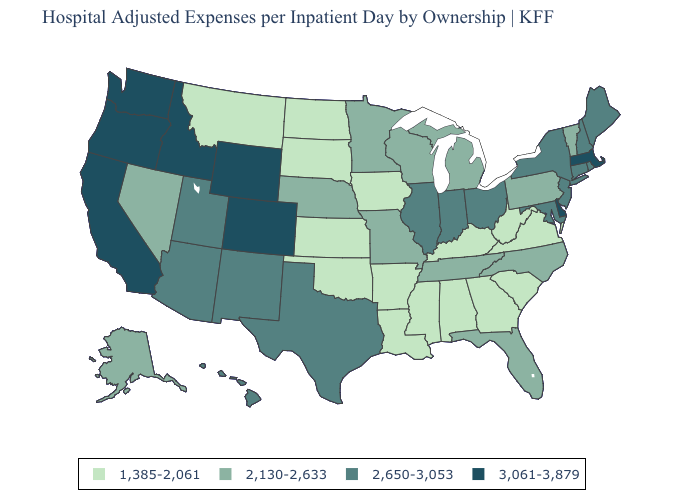Name the states that have a value in the range 2,650-3,053?
Concise answer only. Arizona, Connecticut, Hawaii, Illinois, Indiana, Maine, Maryland, New Hampshire, New Jersey, New Mexico, New York, Ohio, Rhode Island, Texas, Utah. How many symbols are there in the legend?
Answer briefly. 4. What is the lowest value in states that border Nebraska?
Concise answer only. 1,385-2,061. What is the value of Indiana?
Concise answer only. 2,650-3,053. Does North Dakota have the lowest value in the USA?
Short answer required. Yes. Does Colorado have the highest value in the USA?
Short answer required. Yes. Is the legend a continuous bar?
Keep it brief. No. Does Delaware have the highest value in the USA?
Concise answer only. Yes. What is the lowest value in the Northeast?
Give a very brief answer. 2,130-2,633. Which states have the lowest value in the South?
Concise answer only. Alabama, Arkansas, Georgia, Kentucky, Louisiana, Mississippi, Oklahoma, South Carolina, Virginia, West Virginia. What is the lowest value in states that border Nebraska?
Quick response, please. 1,385-2,061. What is the highest value in states that border Utah?
Concise answer only. 3,061-3,879. Does California have the lowest value in the West?
Quick response, please. No. Name the states that have a value in the range 2,650-3,053?
Quick response, please. Arizona, Connecticut, Hawaii, Illinois, Indiana, Maine, Maryland, New Hampshire, New Jersey, New Mexico, New York, Ohio, Rhode Island, Texas, Utah. What is the value of Maine?
Keep it brief. 2,650-3,053. 